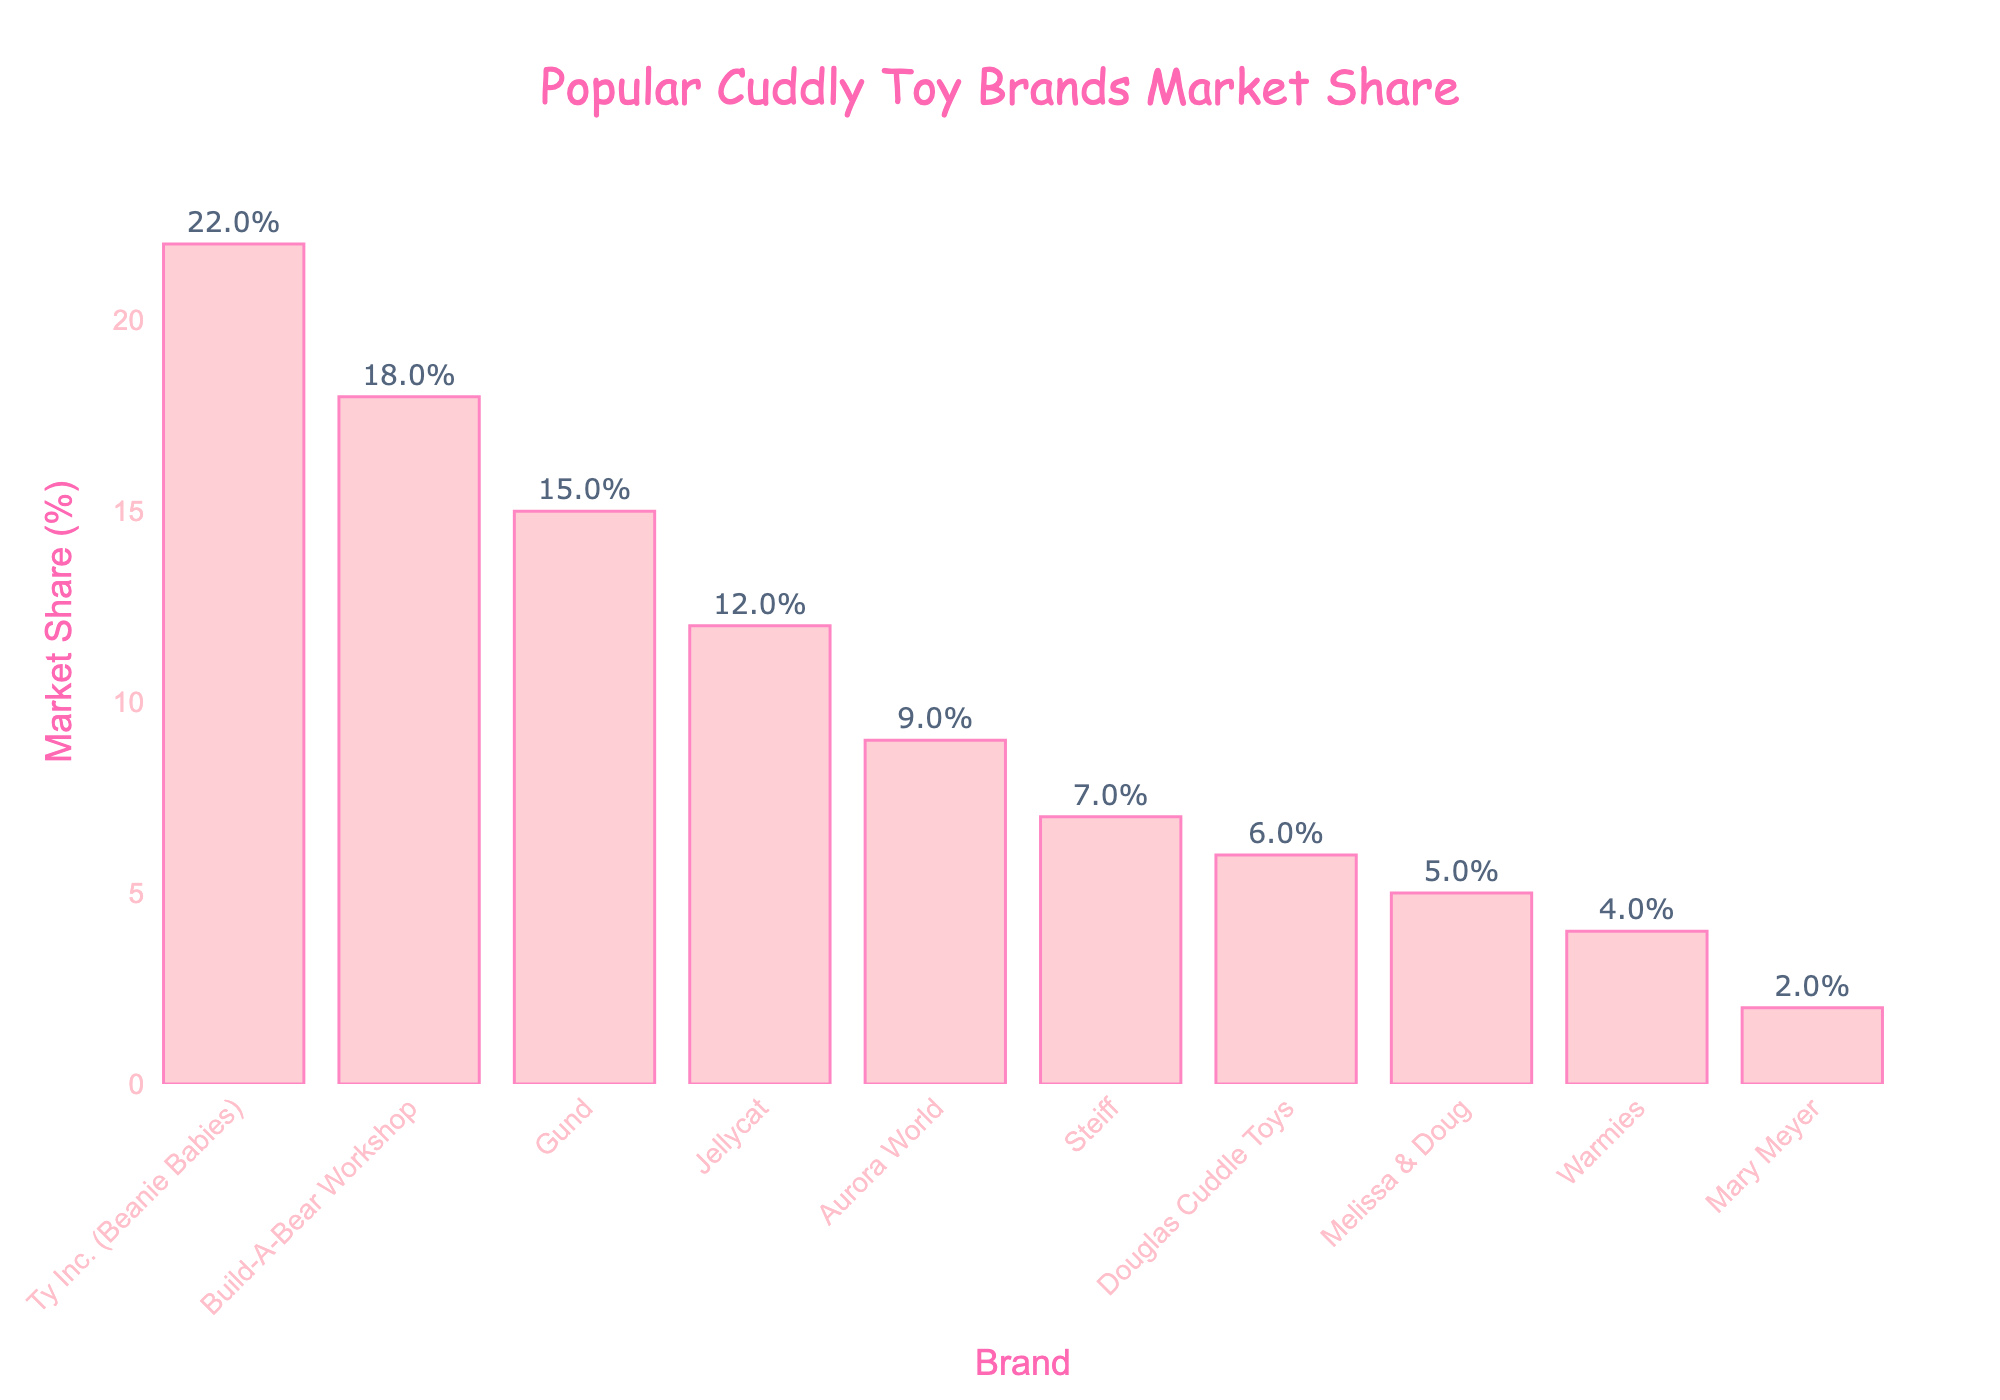What is the market share of Ty Inc. (Beanie Babies)? Look at the bar labeled "Ty Inc. (Beanie Babies)" and read the market share value from the top of the bar, which is 22%.
Answer: 22% Which brand has the smallest market share? The shortest bar represents the brand with the smallest market share, which is Mary Meyer with 2%.
Answer: Mary Meyer How much larger is the market share of Build-A-Bear Workshop compared to Jellycat? Find the difference between the market share of Build-A-Bear Workshop (18%) and Jellycat (12%) by subtracting 12% from 18%.
Answer: 6% What is the total market share of the top three brands? Sum up the market shares of the top three brands: Ty Inc. (Beanie Babies) with 22%, Build-A-Bear Workshop with 18%, and Gund with 15%. The total market share is 22% + 18% + 15% = 55%.
Answer: 55% Which brand has the highest market share and what visual attributes highlight this? The brand with the highest market share is Ty Inc. (Beanie Babies), evident from the tallest bar colored in light pink, standing out significantly above the other bars.
Answer: Ty Inc. (Beanie Babies) How much more market share does Aurora World have compared to Douglas Cuddle Toys? Subtract the market share of Douglas Cuddle Toys (6%) from the market share of Aurora World (9%). The difference is 9% - 6% = 3%.
Answer: 3% What is the combined market share of the brands with less than 10% market share? Identify the brands with less than 10% market share (Aurora World 9%, Steiff 7%, Douglas Cuddle Toys 6%, Melissa & Doug 5%, Warmies 4%, Mary Meyer 2%) and sum up their market shares: 9% + 7% + 6% + 5% + 4% + 2% = 33%.
Answer: 33% Which brand holds exactly half the market share of Ty Inc. (Beanie Babies)? Half of Ty Inc. (Beanie Babies)’s market share (22%) is 11%. Look for the brand closest to this value, which is Jellycat with 12%.
Answer: Jellycat How many brands have a market share of at least 5% but less than 10%? Count the bars that fall within the range of 5% to 9%, which are Aurora World (9%), Steiff (7%), and Douglas Cuddle Toys (6%). There are three brands in this range.
Answer: 3 What is the difference in market share between the second-highest and the third-highest brands? Compare the market shares of the second-highest (Build-A-Bear Workshop with 18%) and third-highest (Gund with 15%) brands. Subtract 15% from 18% to find the difference, which is 3%.
Answer: 3% 